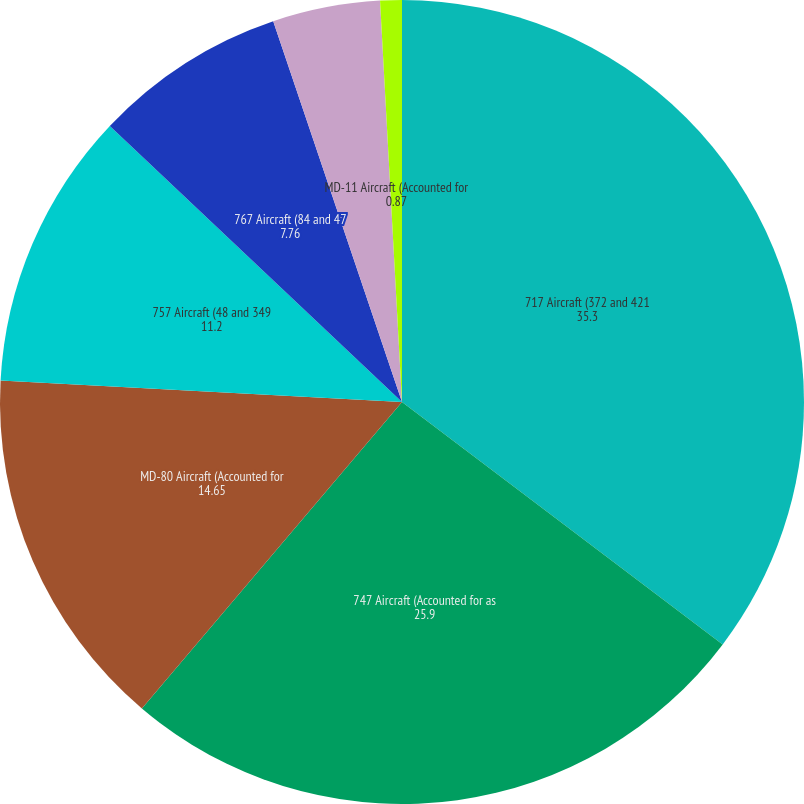<chart> <loc_0><loc_0><loc_500><loc_500><pie_chart><fcel>717 Aircraft (372 and 421<fcel>747 Aircraft (Accounted for as<fcel>MD-80 Aircraft (Accounted for<fcel>757 Aircraft (48 and 349<fcel>767 Aircraft (84 and 47<fcel>737 Aircraft (115 and 127<fcel>MD-11 Aircraft (Accounted for<nl><fcel>35.3%<fcel>25.9%<fcel>14.65%<fcel>11.2%<fcel>7.76%<fcel>4.32%<fcel>0.87%<nl></chart> 